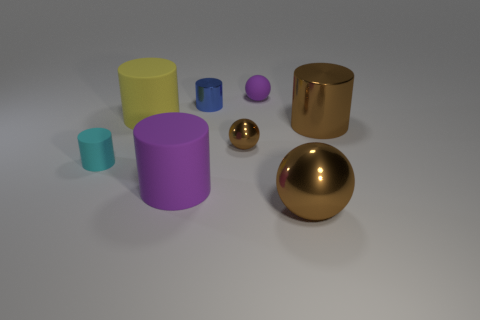Subtract 1 cylinders. How many cylinders are left? 4 Subtract all big purple cylinders. How many cylinders are left? 4 Subtract all purple cylinders. How many cylinders are left? 4 Subtract all green cylinders. Subtract all green balls. How many cylinders are left? 5 Add 1 rubber cylinders. How many objects exist? 9 Subtract all cylinders. How many objects are left? 3 Subtract 2 brown balls. How many objects are left? 6 Subtract all large gray rubber objects. Subtract all purple matte objects. How many objects are left? 6 Add 3 big rubber things. How many big rubber things are left? 5 Add 2 yellow rubber spheres. How many yellow rubber spheres exist? 2 